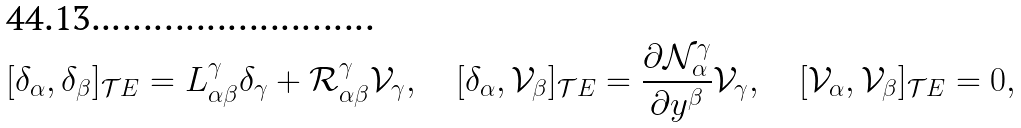Convert formula to latex. <formula><loc_0><loc_0><loc_500><loc_500>[ \delta _ { \alpha } , \delta _ { \beta } ] _ { \mathcal { T } E } = L _ { \alpha \beta } ^ { \gamma } \delta _ { \gamma } + \mathcal { R } _ { \alpha \beta } ^ { \gamma } \mathcal { V } _ { \gamma } , \quad [ \delta _ { \alpha } , \mathcal { V } _ { \beta } ] _ { \mathcal { T } E } = \frac { \partial \mathcal { N } _ { \alpha } ^ { \gamma } } { \partial y ^ { \beta } } \mathcal { V } _ { \gamma } , \quad [ \mathcal { V } _ { \alpha } , \mathcal { V } _ { \beta } ] _ { \mathcal { T } E } = 0 ,</formula> 